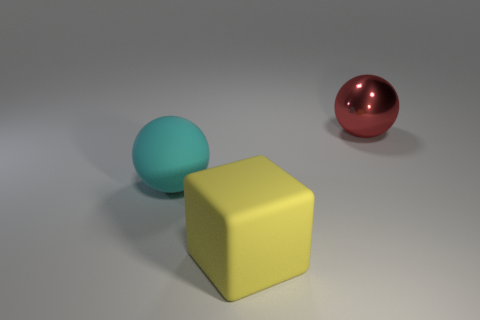Is the large object right of the yellow block made of the same material as the large ball that is in front of the red sphere?
Your answer should be compact. No. How many large yellow cubes are right of the large block?
Ensure brevity in your answer.  0. What number of cyan things are rubber spheres or shiny blocks?
Your answer should be compact. 1. What material is the cyan thing that is the same size as the yellow thing?
Your answer should be compact. Rubber. There is a object that is to the left of the red metallic ball and behind the big yellow thing; what shape is it?
Offer a very short reply. Sphere. There is a ball that is the same size as the red thing; what color is it?
Ensure brevity in your answer.  Cyan. There is a sphere on the left side of the rubber cube; is it the same size as the thing on the right side of the yellow matte cube?
Offer a terse response. Yes. There is a cyan sphere that is left of the matte object right of the sphere to the left of the metallic sphere; what is its size?
Make the answer very short. Large. The object that is in front of the large ball that is left of the big metal sphere is what shape?
Offer a terse response. Cube. Do the large matte sphere behind the big yellow rubber thing and the rubber block have the same color?
Give a very brief answer. No. 